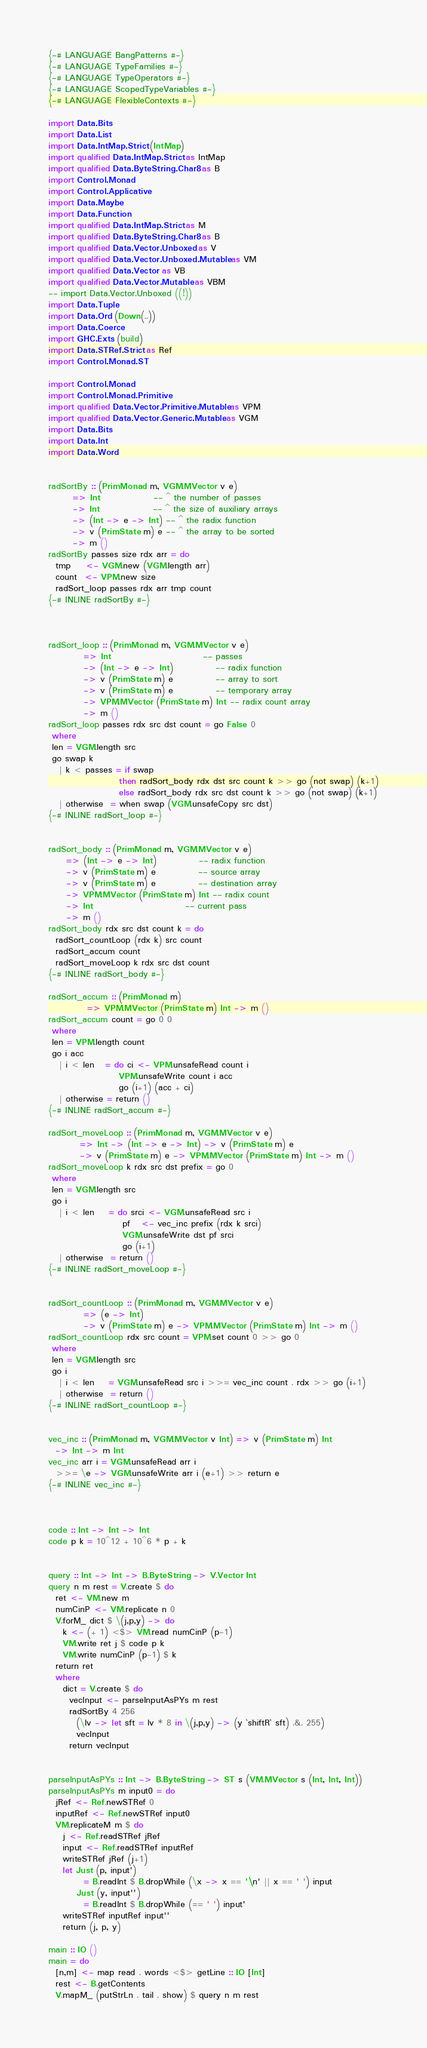<code> <loc_0><loc_0><loc_500><loc_500><_Haskell_>{-# LANGUAGE BangPatterns #-}
{-# LANGUAGE TypeFamilies #-}
{-# LANGUAGE TypeOperators #-}
{-# LANGUAGE ScopedTypeVariables #-}
{-# LANGUAGE FlexibleContexts #-}

import Data.Bits
import Data.List
import Data.IntMap.Strict (IntMap)
import qualified Data.IntMap.Strict as IntMap
import qualified Data.ByteString.Char8 as B
import Control.Monad
import Control.Applicative
import Data.Maybe
import Data.Function
import qualified Data.IntMap.Strict as M
import qualified Data.ByteString.Char8 as B
import qualified Data.Vector.Unboxed as V
import qualified Data.Vector.Unboxed.Mutable as VM
import qualified Data.Vector as VB
import qualified Data.Vector.Mutable as VBM
-- import Data.Vector.Unboxed ((!))
import Data.Tuple
import Data.Ord (Down(..))
import Data.Coerce
import GHC.Exts (build)
import Data.STRef.Strict as Ref
import Control.Monad.ST

import Control.Monad
import Control.Monad.Primitive
import qualified Data.Vector.Primitive.Mutable as VPM
import qualified Data.Vector.Generic.Mutable as VGM
import Data.Bits
import Data.Int
import Data.Word


radSortBy :: (PrimMonad m, VGM.MVector v e)
       => Int               -- ^ the number of passes
       -> Int               -- ^ the size of auxiliary arrays
       -> (Int -> e -> Int) -- ^ the radix function
       -> v (PrimState m) e -- ^ the array to be sorted
       -> m ()
radSortBy passes size rdx arr = do
  tmp    <- VGM.new (VGM.length arr)
  count  <- VPM.new size
  radSort_loop passes rdx arr tmp count
{-# INLINE radSortBy #-}



radSort_loop :: (PrimMonad m, VGM.MVector v e)
          => Int                          -- passes
          -> (Int -> e -> Int)            -- radix function
          -> v (PrimState m) e            -- array to sort
          -> v (PrimState m) e            -- temporary array
          -> VPM.MVector (PrimState m) Int -- radix count array
          -> m ()
radSort_loop passes rdx src dst count = go False 0
 where
 len = VGM.length src
 go swap k
   | k < passes = if swap
                    then radSort_body rdx dst src count k >> go (not swap) (k+1)
                    else radSort_body rdx src dst count k >> go (not swap) (k+1)
   | otherwise  = when swap (VGM.unsafeCopy src dst)
{-# INLINE radSort_loop #-}


radSort_body :: (PrimMonad m, VGM.MVector v e)
     => (Int -> e -> Int)            -- radix function
     -> v (PrimState m) e            -- source array
     -> v (PrimState m) e            -- destination array
     -> VPM.MVector (PrimState m) Int -- radix count
     -> Int                          -- current pass
     -> m ()
radSort_body rdx src dst count k = do
  radSort_countLoop (rdx k) src count
  radSort_accum count
  radSort_moveLoop k rdx src dst count
{-# INLINE radSort_body #-}

radSort_accum :: (PrimMonad m)
           => VPM.MVector (PrimState m) Int -> m ()
radSort_accum count = go 0 0
 where
 len = VPM.length count
 go i acc
   | i < len   = do ci <- VPM.unsafeRead count i
                    VPM.unsafeWrite count i acc
                    go (i+1) (acc + ci)
   | otherwise = return ()
{-# INLINE radSort_accum #-}

radSort_moveLoop :: (PrimMonad m, VGM.MVector v e)
         => Int -> (Int -> e -> Int) -> v (PrimState m) e
         -> v (PrimState m) e -> VPM.MVector (PrimState m) Int -> m ()
radSort_moveLoop k rdx src dst prefix = go 0
 where
 len = VGM.length src
 go i
   | i < len    = do srci <- VGM.unsafeRead src i
                     pf   <- vec_inc prefix (rdx k srci)
                     VGM.unsafeWrite dst pf srci
                     go (i+1)
   | otherwise  = return ()
{-# INLINE radSort_moveLoop #-}


radSort_countLoop :: (PrimMonad m, VGM.MVector v e)
          => (e -> Int)
          -> v (PrimState m) e -> VPM.MVector (PrimState m) Int -> m ()
radSort_countLoop rdx src count = VPM.set count 0 >> go 0
 where
 len = VGM.length src
 go i
   | i < len    = VGM.unsafeRead src i >>= vec_inc count . rdx >> go (i+1)
   | otherwise  = return ()
{-# INLINE radSort_countLoop #-}


vec_inc :: (PrimMonad m, VGM.MVector v Int) => v (PrimState m) Int
  -> Int -> m Int
vec_inc arr i = VGM.unsafeRead arr i
  >>= \e -> VGM.unsafeWrite arr i (e+1) >> return e
{-# INLINE vec_inc #-}



code :: Int -> Int -> Int
code p k = 10^12 + 10^6 * p + k


query :: Int -> Int -> B.ByteString -> V.Vector Int
query n m rest = V.create $ do
  ret <- VM.new m
  numCinP <- VM.replicate n 0
  V.forM_ dict $ \(j,p,y) -> do
    k <- (+ 1) <$> VM.read numCinP (p-1)
    VM.write ret j $ code p k
    VM.write numCinP (p-1) $ k
  return ret
  where
    dict = V.create $ do
      vecInput <- parseInputAsPYs m rest
      radSortBy 4 256
        (\lv -> let sft = lv * 8 in \(j,p,y) -> (y `shiftR` sft) .&. 255)
        vecInput
      return vecInput
  

parseInputAsPYs :: Int -> B.ByteString -> ST s (VM.MVector s (Int, Int, Int))
parseInputAsPYs m input0 = do
  jRef <- Ref.newSTRef 0
  inputRef <- Ref.newSTRef input0
  VM.replicateM m $ do
    j <- Ref.readSTRef jRef
    input <- Ref.readSTRef inputRef
    writeSTRef jRef (j+1)
    let Just (p, input')
          = B.readInt $ B.dropWhile (\x -> x == '\n' || x == ' ') input
        Just (y, input'')
          = B.readInt $ B.dropWhile (== ' ') input'
    writeSTRef inputRef input''
    return (j, p, y)
    
main :: IO ()
main = do
  [n,m] <- map read . words <$> getLine :: IO [Int]
  rest <- B.getContents
  V.mapM_ (putStrLn . tail . show) $ query n m rest
</code> 